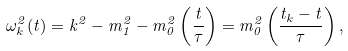<formula> <loc_0><loc_0><loc_500><loc_500>\omega ^ { 2 } _ { k } ( t ) = { k } ^ { 2 } - m _ { 1 } ^ { 2 } - m _ { 0 } ^ { 2 } \left ( \frac { t } { \tau } \right ) = m _ { 0 } ^ { 2 } \left ( \frac { t _ { k } - t } { \tau } \right ) ,</formula> 